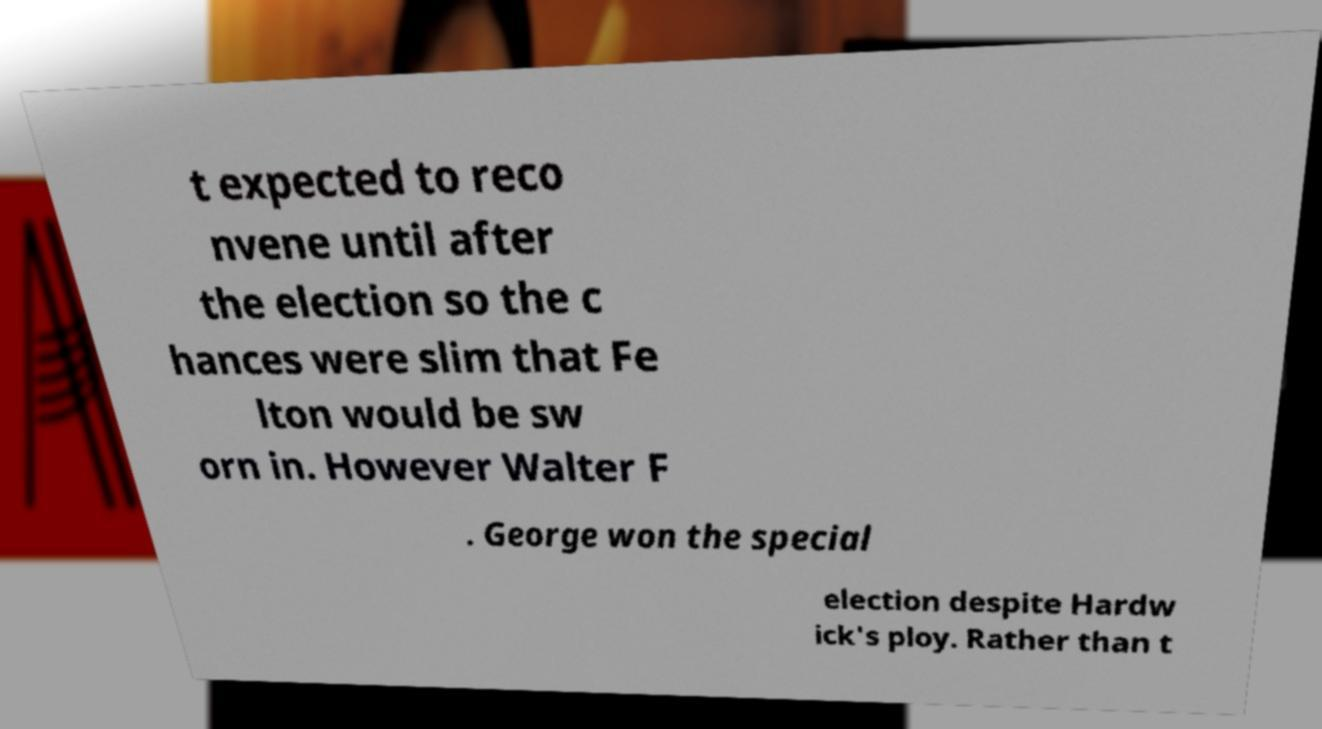What messages or text are displayed in this image? I need them in a readable, typed format. t expected to reco nvene until after the election so the c hances were slim that Fe lton would be sw orn in. However Walter F . George won the special election despite Hardw ick's ploy. Rather than t 